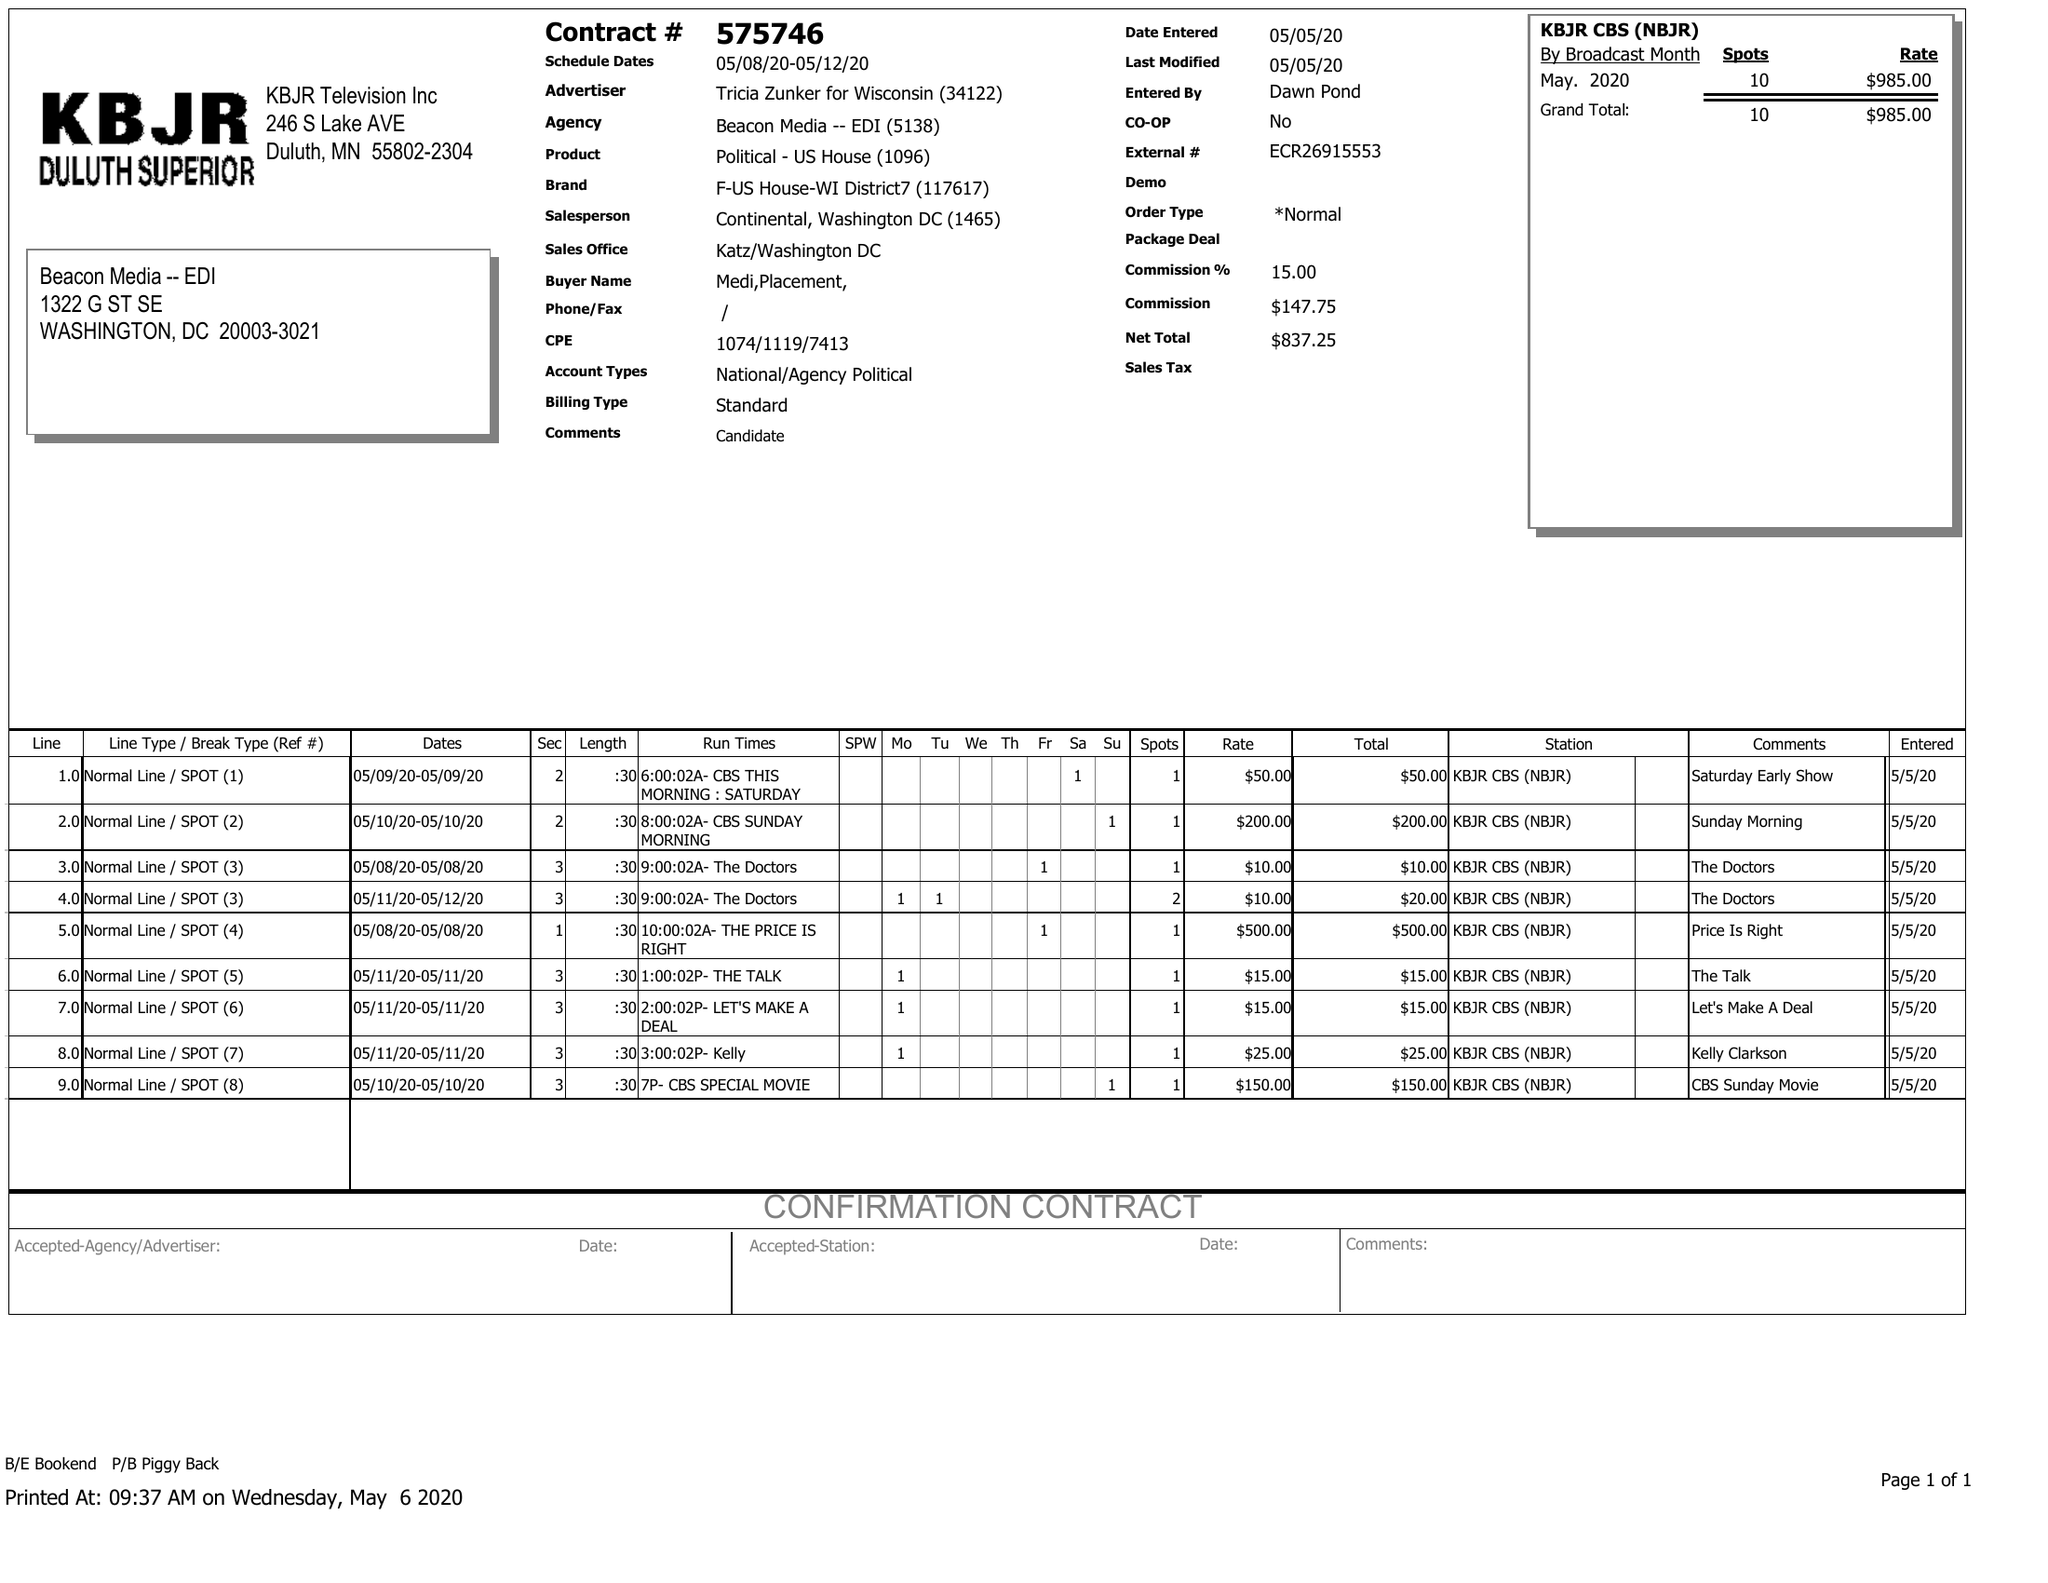What is the value for the flight_from?
Answer the question using a single word or phrase. 05/08/20 